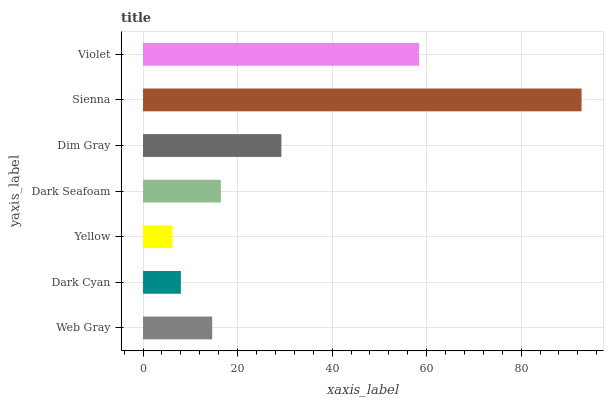Is Yellow the minimum?
Answer yes or no. Yes. Is Sienna the maximum?
Answer yes or no. Yes. Is Dark Cyan the minimum?
Answer yes or no. No. Is Dark Cyan the maximum?
Answer yes or no. No. Is Web Gray greater than Dark Cyan?
Answer yes or no. Yes. Is Dark Cyan less than Web Gray?
Answer yes or no. Yes. Is Dark Cyan greater than Web Gray?
Answer yes or no. No. Is Web Gray less than Dark Cyan?
Answer yes or no. No. Is Dark Seafoam the high median?
Answer yes or no. Yes. Is Dark Seafoam the low median?
Answer yes or no. Yes. Is Dark Cyan the high median?
Answer yes or no. No. Is Violet the low median?
Answer yes or no. No. 